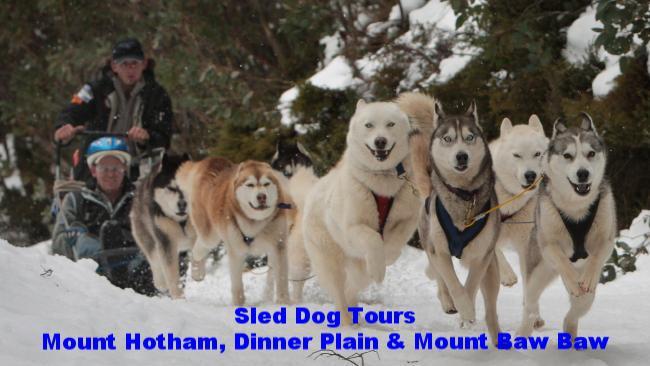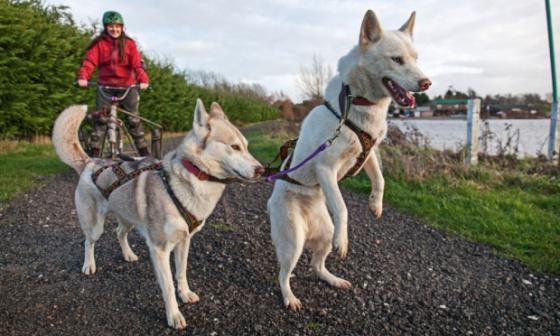The first image is the image on the left, the second image is the image on the right. Considering the images on both sides, is "The left image shows a sled dog team heading forward over snow, and the right image shows dogs hitched to a forward-facing wheeled vehicle on a path bare of snow." valid? Answer yes or no. Yes. The first image is the image on the left, the second image is the image on the right. Analyze the images presented: Is the assertion "All of the dogs are moving forward." valid? Answer yes or no. No. 